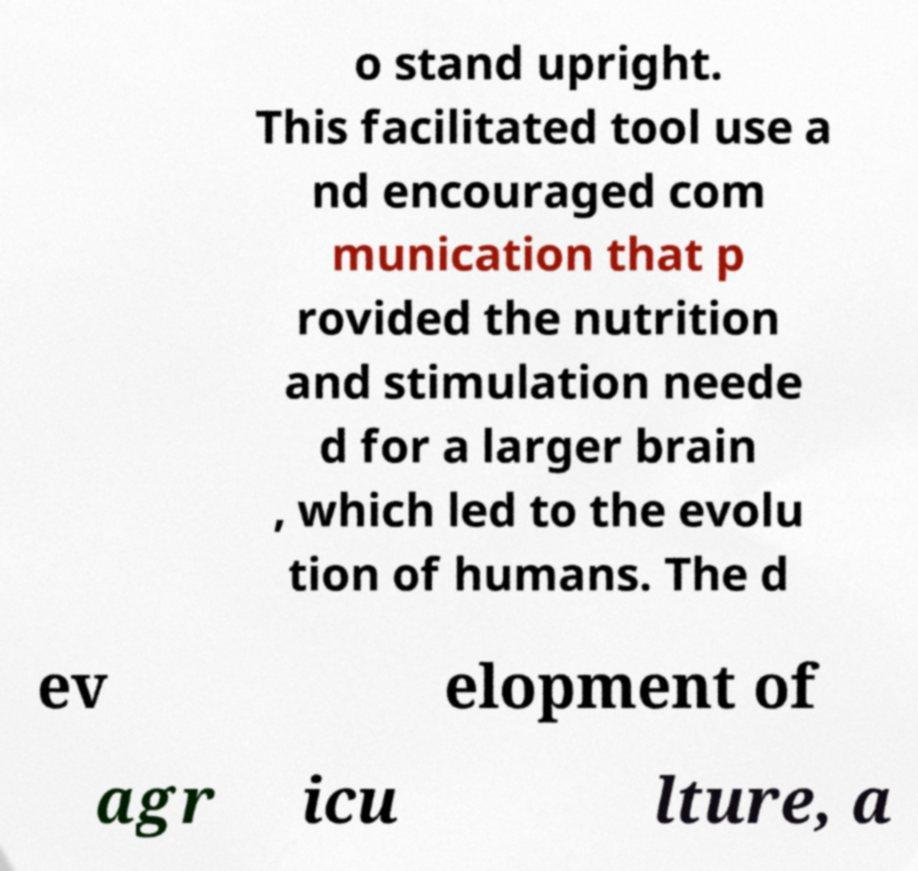There's text embedded in this image that I need extracted. Can you transcribe it verbatim? o stand upright. This facilitated tool use a nd encouraged com munication that p rovided the nutrition and stimulation neede d for a larger brain , which led to the evolu tion of humans. The d ev elopment of agr icu lture, a 